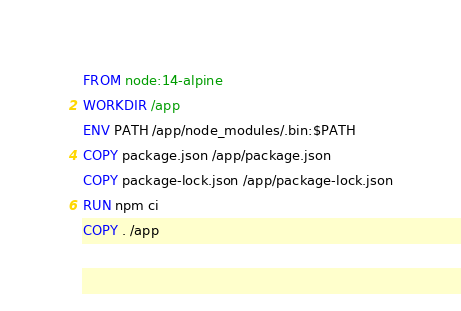<code> <loc_0><loc_0><loc_500><loc_500><_Dockerfile_>FROM node:14-alpine
WORKDIR /app
ENV PATH /app/node_modules/.bin:$PATH
COPY package.json /app/package.json
COPY package-lock.json /app/package-lock.json
RUN npm ci
COPY . /app</code> 